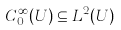Convert formula to latex. <formula><loc_0><loc_0><loc_500><loc_500>C _ { 0 } ^ { \infty } ( U ) \subseteq L ^ { 2 } ( U )</formula> 